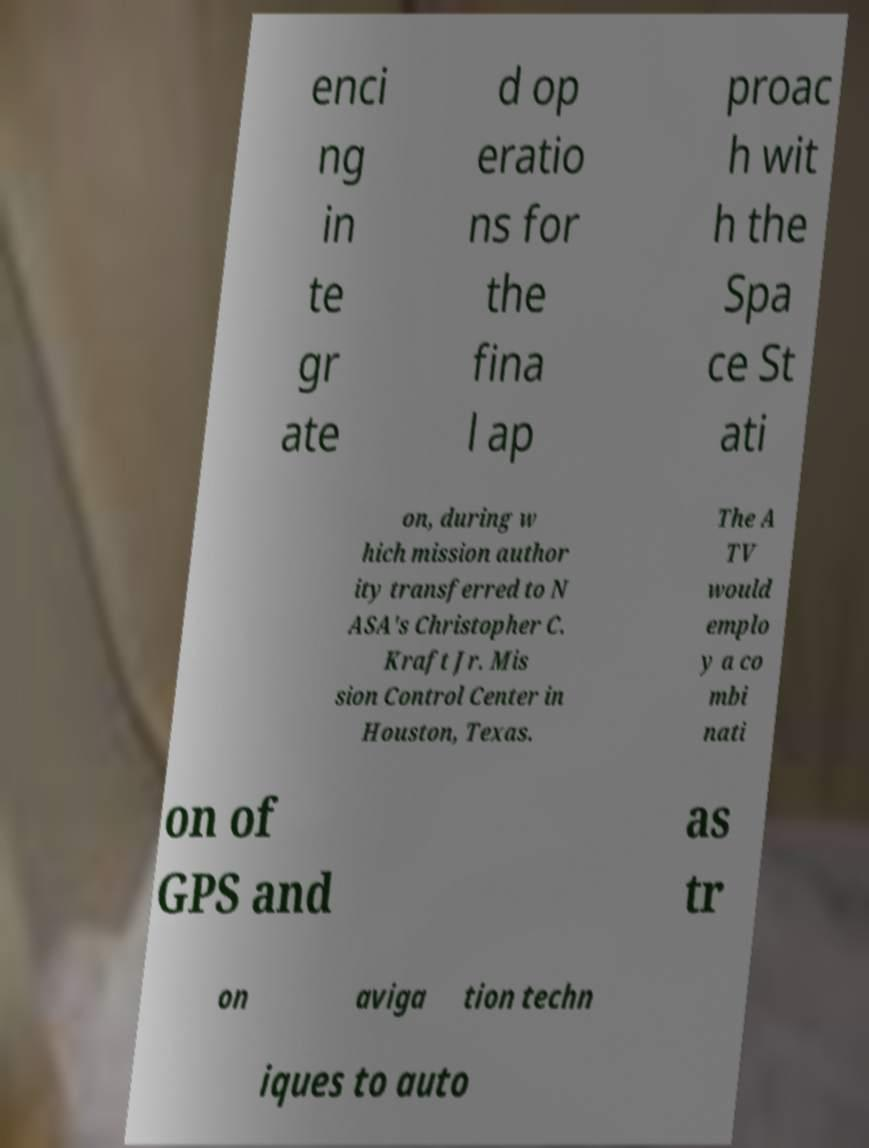What messages or text are displayed in this image? I need them in a readable, typed format. enci ng in te gr ate d op eratio ns for the fina l ap proac h wit h the Spa ce St ati on, during w hich mission author ity transferred to N ASA's Christopher C. Kraft Jr. Mis sion Control Center in Houston, Texas. The A TV would emplo y a co mbi nati on of GPS and as tr on aviga tion techn iques to auto 